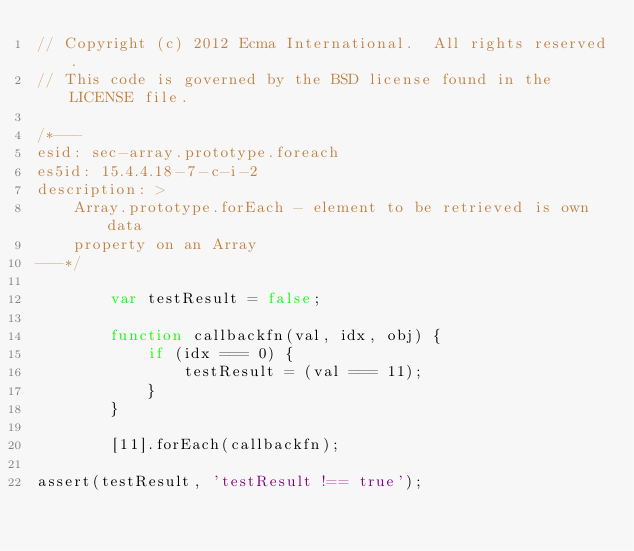Convert code to text. <code><loc_0><loc_0><loc_500><loc_500><_JavaScript_>// Copyright (c) 2012 Ecma International.  All rights reserved.
// This code is governed by the BSD license found in the LICENSE file.

/*---
esid: sec-array.prototype.foreach
es5id: 15.4.4.18-7-c-i-2
description: >
    Array.prototype.forEach - element to be retrieved is own data
    property on an Array
---*/

        var testResult = false;

        function callbackfn(val, idx, obj) {
            if (idx === 0) {
                testResult = (val === 11);
            }
        }

        [11].forEach(callbackfn);

assert(testResult, 'testResult !== true');
</code> 